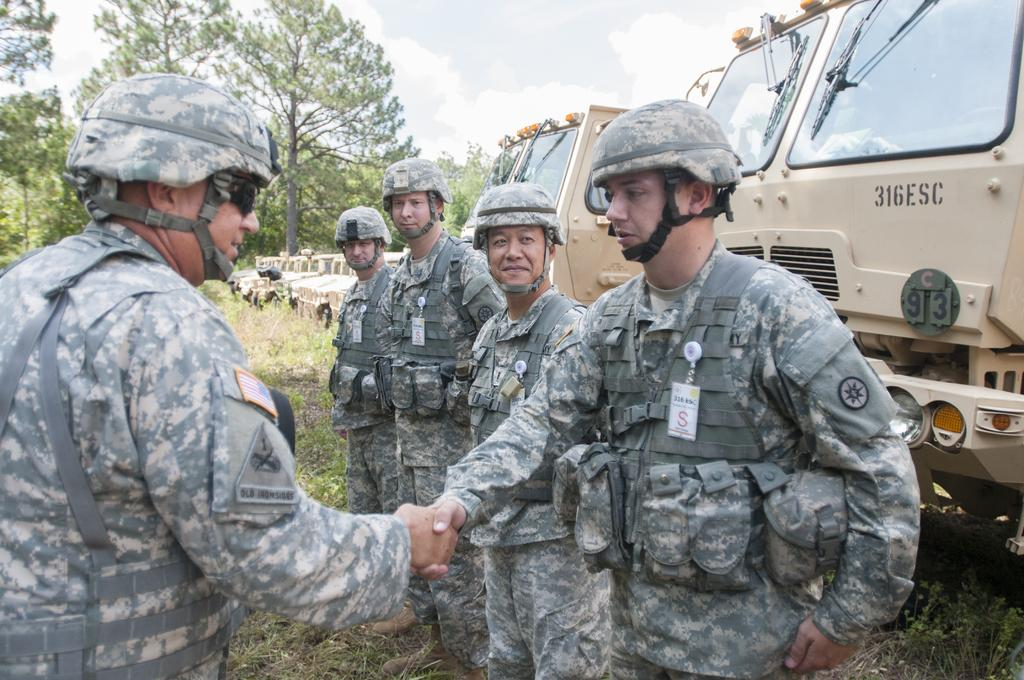<image>
Present a compact description of the photo's key features. A military truck with 316ESC on it behind a group of soldiers. 